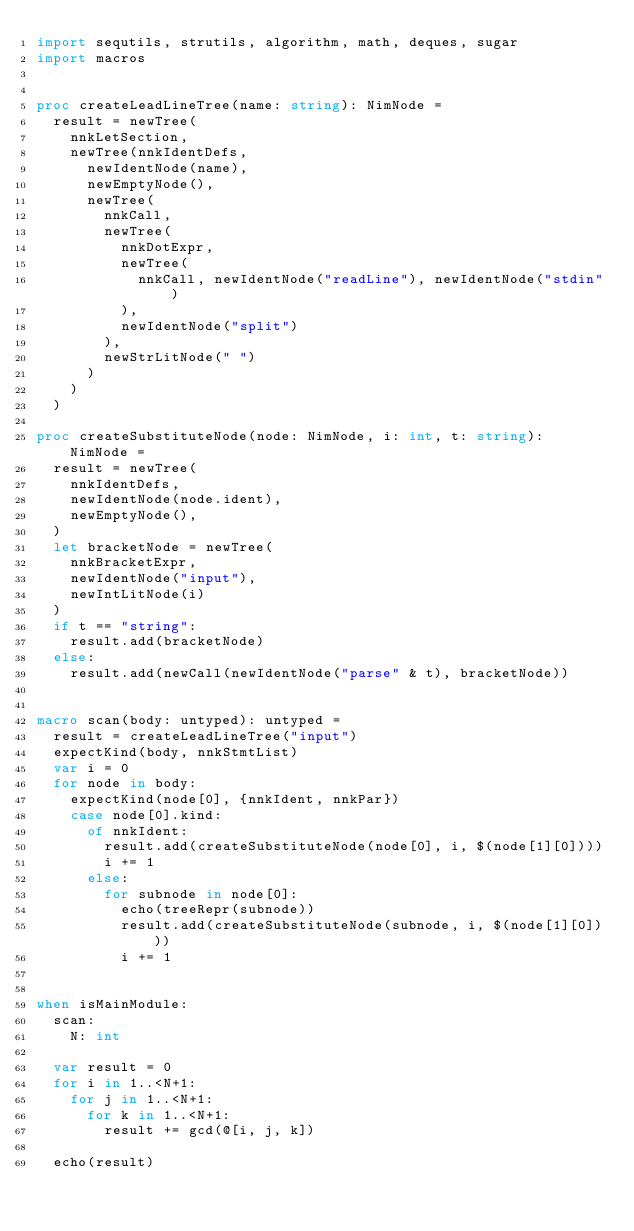<code> <loc_0><loc_0><loc_500><loc_500><_Nim_>import sequtils, strutils, algorithm, math, deques, sugar
import macros


proc createLeadLineTree(name: string): NimNode =
  result = newTree(
    nnkLetSection,
    newTree(nnkIdentDefs,
      newIdentNode(name),
      newEmptyNode(),
      newTree(
        nnkCall,
        newTree(
          nnkDotExpr,
          newTree(
            nnkCall, newIdentNode("readLine"), newIdentNode("stdin")
          ),
          newIdentNode("split")
        ),
        newStrLitNode(" ")
      )
    )
  )

proc createSubstituteNode(node: NimNode, i: int, t: string): NimNode =
  result = newTree(
    nnkIdentDefs, 
    newIdentNode(node.ident),
    newEmptyNode(),
  )
  let bracketNode = newTree(
    nnkBracketExpr,
    newIdentNode("input"),
    newIntLitNode(i)
  )
  if t == "string":
    result.add(bracketNode)
  else:
    result.add(newCall(newIdentNode("parse" & t), bracketNode))


macro scan(body: untyped): untyped =
  result = createLeadLineTree("input")
  expectKind(body, nnkStmtList)
  var i = 0
  for node in body:
    expectKind(node[0], {nnkIdent, nnkPar})
    case node[0].kind:
      of nnkIdent:
        result.add(createSubstituteNode(node[0], i, $(node[1][0])))
        i += 1
      else:
        for subnode in node[0]:
          echo(treeRepr(subnode))
          result.add(createSubstituteNode(subnode, i, $(node[1][0])))
          i += 1


when isMainModule:
  scan:
    N: int
  
  var result = 0
  for i in 1..<N+1:
    for j in 1..<N+1:
      for k in 1..<N+1:
        result += gcd(@[i, j, k])

  echo(result)</code> 